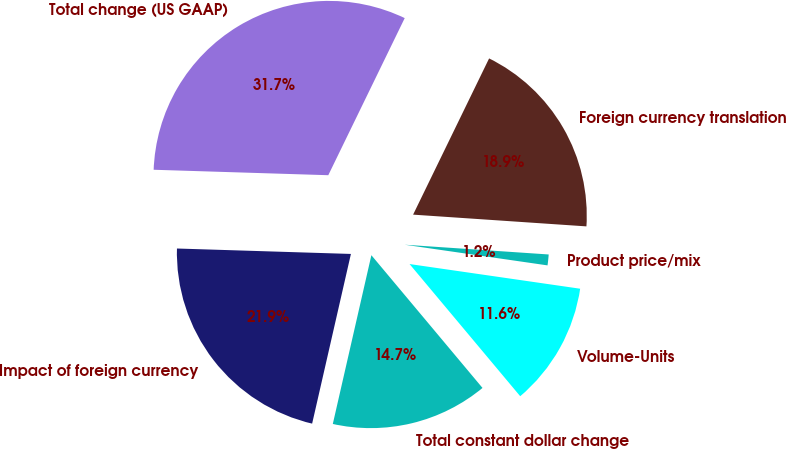Convert chart to OTSL. <chart><loc_0><loc_0><loc_500><loc_500><pie_chart><fcel>Volume-Units<fcel>Product price/mix<fcel>Foreign currency translation<fcel>Total change (US GAAP)<fcel>Impact of foreign currency<fcel>Total constant dollar change<nl><fcel>11.62%<fcel>1.21%<fcel>18.87%<fcel>31.71%<fcel>21.92%<fcel>14.67%<nl></chart> 